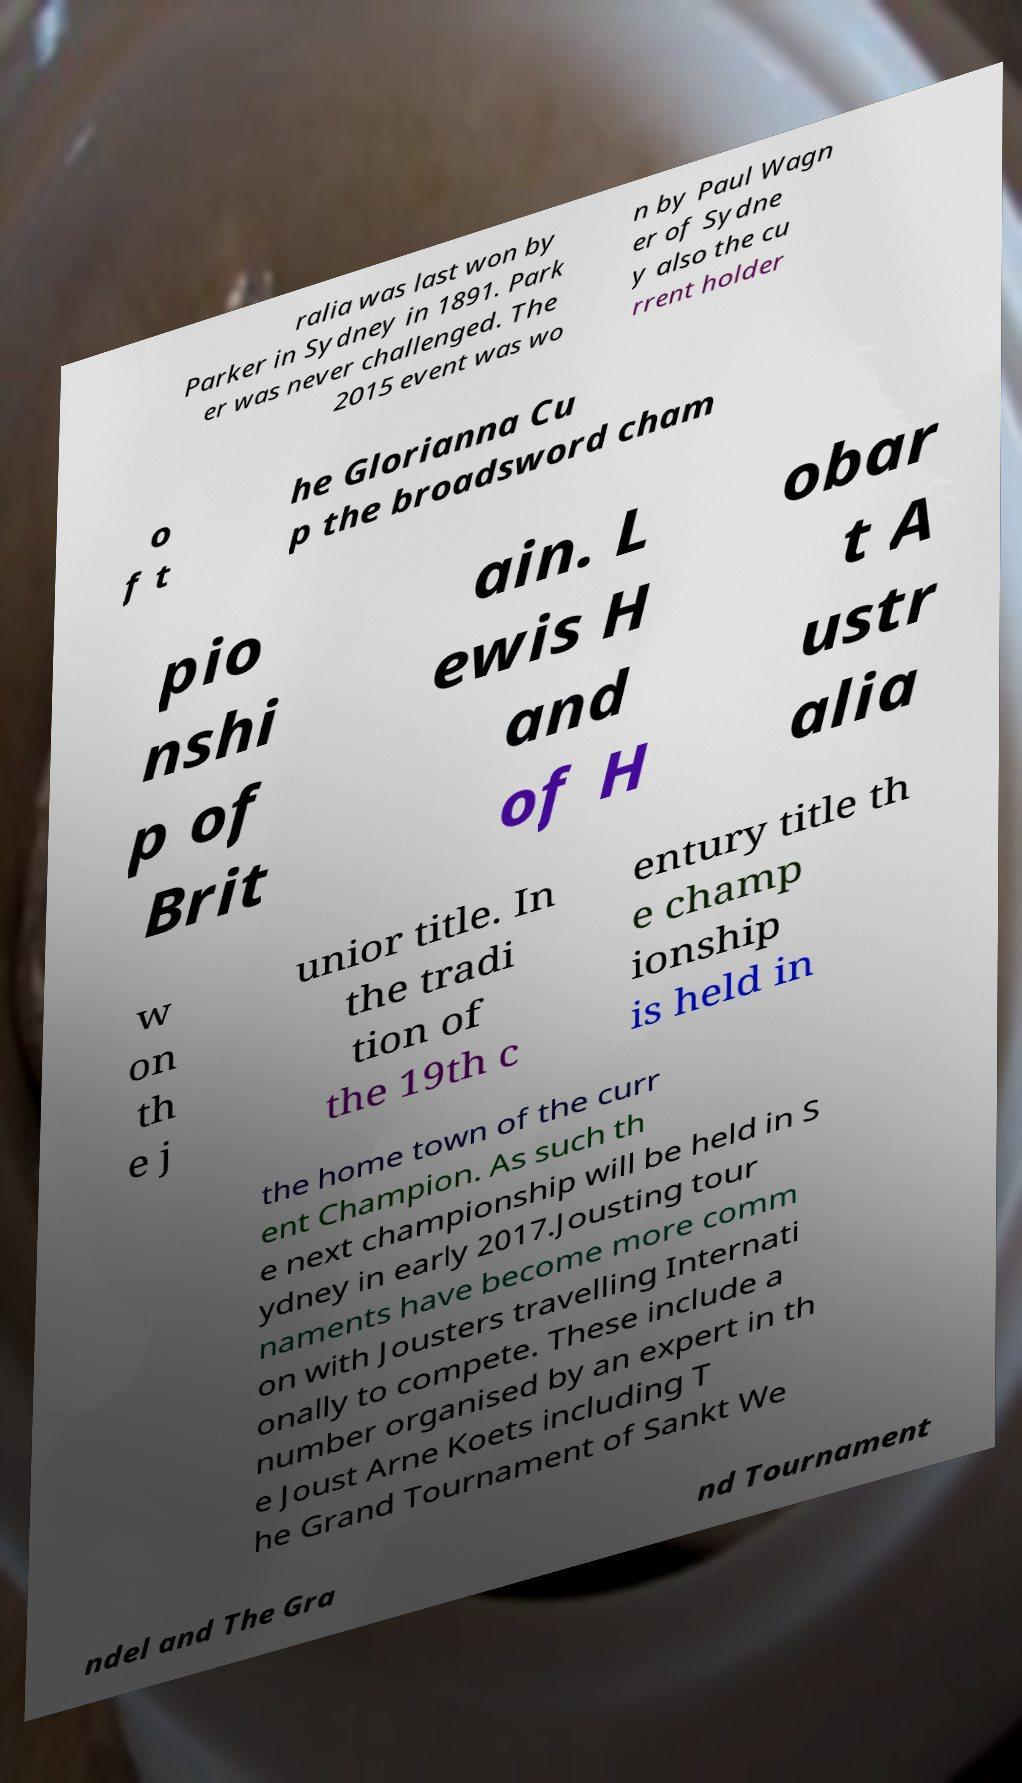Can you accurately transcribe the text from the provided image for me? ralia was last won by Parker in Sydney in 1891. Park er was never challenged. The 2015 event was wo n by Paul Wagn er of Sydne y also the cu rrent holder o f t he Glorianna Cu p the broadsword cham pio nshi p of Brit ain. L ewis H and of H obar t A ustr alia w on th e j unior title. In the tradi tion of the 19th c entury title th e champ ionship is held in the home town of the curr ent Champion. As such th e next championship will be held in S ydney in early 2017.Jousting tour naments have become more comm on with Jousters travelling Internati onally to compete. These include a number organised by an expert in th e Joust Arne Koets including T he Grand Tournament of Sankt We ndel and The Gra nd Tournament 